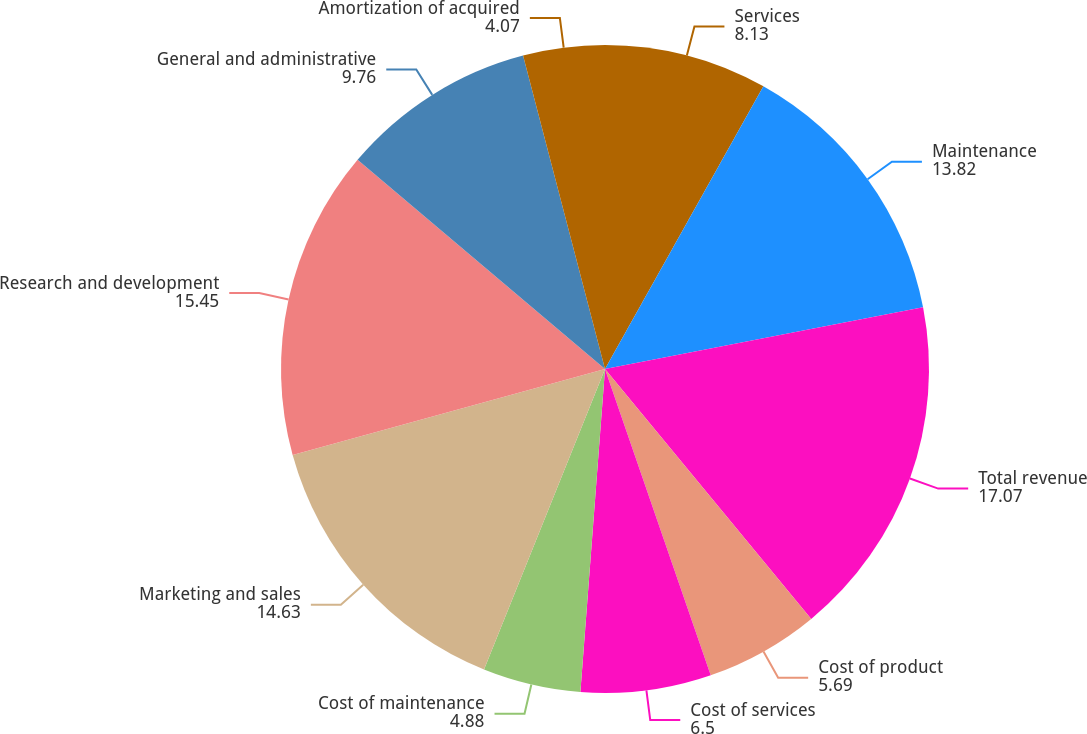Convert chart to OTSL. <chart><loc_0><loc_0><loc_500><loc_500><pie_chart><fcel>Services<fcel>Maintenance<fcel>Total revenue<fcel>Cost of product<fcel>Cost of services<fcel>Cost of maintenance<fcel>Marketing and sales<fcel>Research and development<fcel>General and administrative<fcel>Amortization of acquired<nl><fcel>8.13%<fcel>13.82%<fcel>17.07%<fcel>5.69%<fcel>6.5%<fcel>4.88%<fcel>14.63%<fcel>15.45%<fcel>9.76%<fcel>4.07%<nl></chart> 